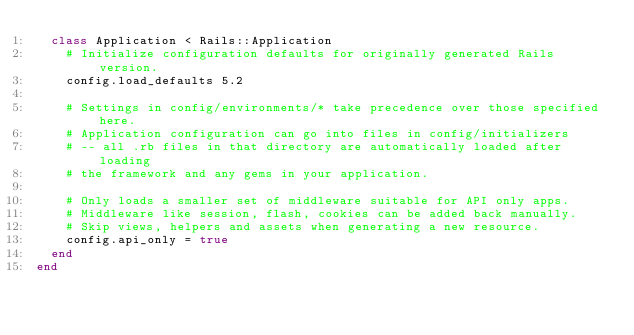Convert code to text. <code><loc_0><loc_0><loc_500><loc_500><_Ruby_>  class Application < Rails::Application
    # Initialize configuration defaults for originally generated Rails version.
    config.load_defaults 5.2

    # Settings in config/environments/* take precedence over those specified here.
    # Application configuration can go into files in config/initializers
    # -- all .rb files in that directory are automatically loaded after loading
    # the framework and any gems in your application.

    # Only loads a smaller set of middleware suitable for API only apps.
    # Middleware like session, flash, cookies can be added back manually.
    # Skip views, helpers and assets when generating a new resource.
    config.api_only = true
  end
end
</code> 